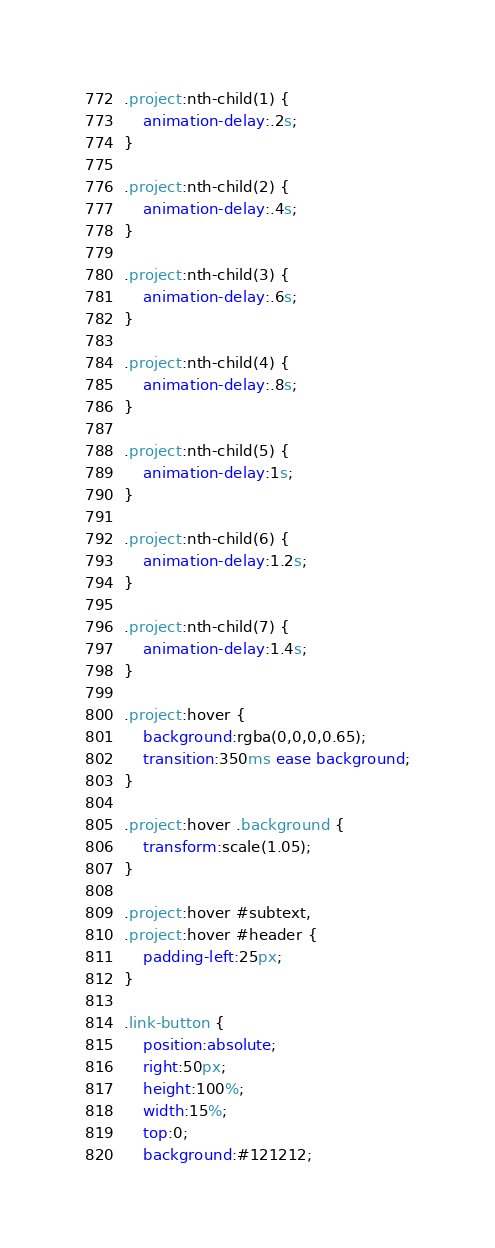<code> <loc_0><loc_0><loc_500><loc_500><_CSS_>.project:nth-child(1) {
    animation-delay:.2s;
}

.project:nth-child(2) {
    animation-delay:.4s;
}

.project:nth-child(3) {
    animation-delay:.6s;
}

.project:nth-child(4) {
    animation-delay:.8s;
}

.project:nth-child(5) {
    animation-delay:1s;
}

.project:nth-child(6) {
    animation-delay:1.2s;
}

.project:nth-child(7) {
    animation-delay:1.4s;
}

.project:hover {
    background:rgba(0,0,0,0.65);
    transition:350ms ease background;
}

.project:hover .background {
    transform:scale(1.05);
}

.project:hover #subtext,
.project:hover #header {
    padding-left:25px;
}

.link-button {
    position:absolute;
    right:50px;
    height:100%;
    width:15%;
    top:0;
    background:#121212;</code> 